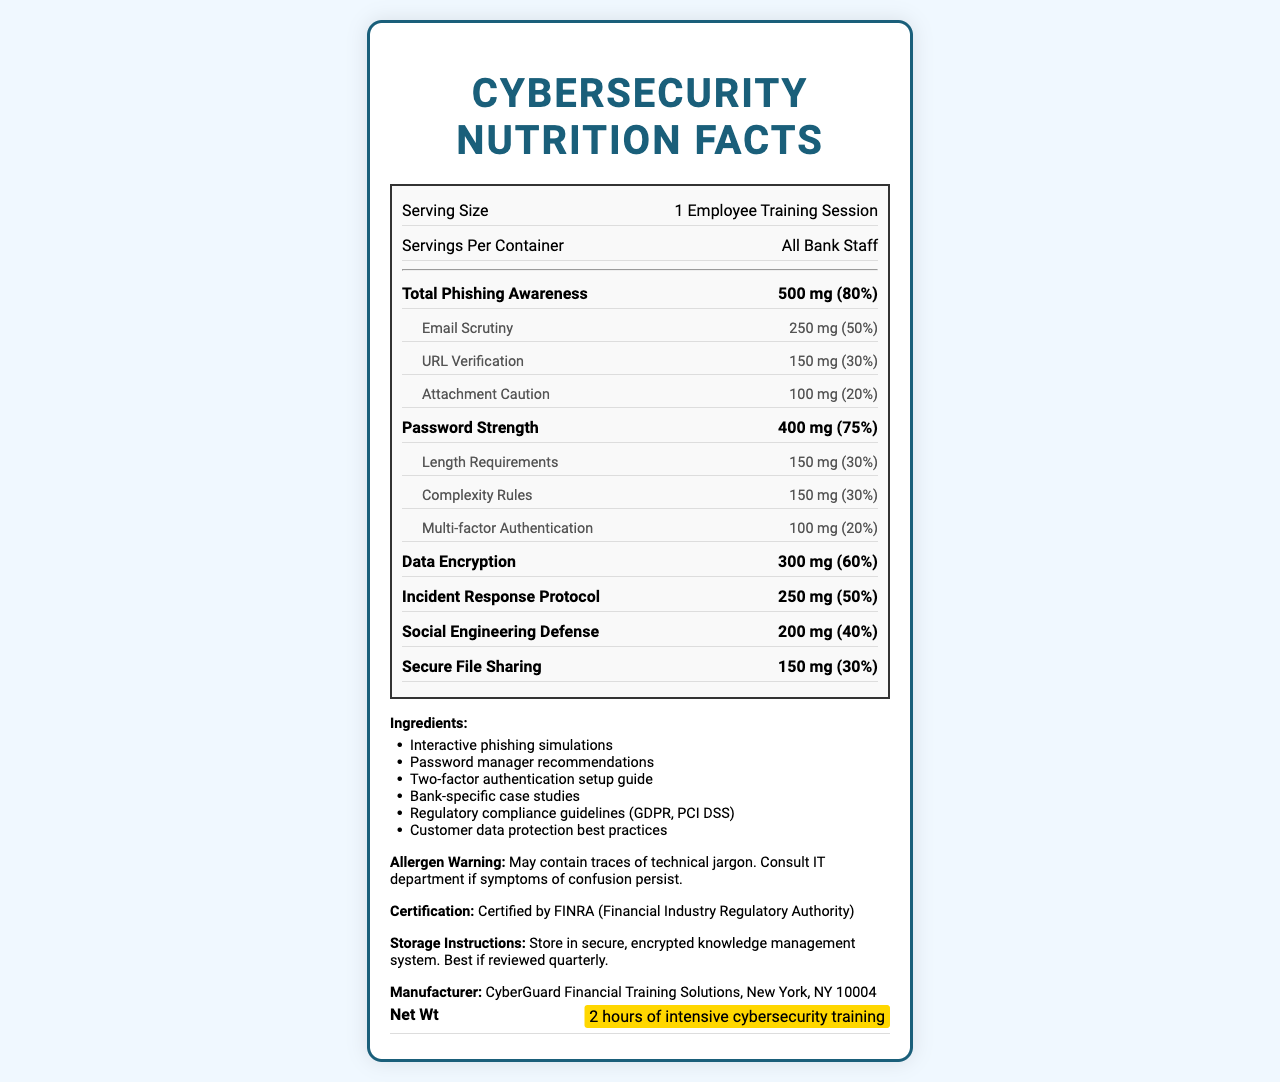what is the serving size? The serving size is mentioned at the top of the document as "Serving Size: 1 Employee Training Session".
Answer: 1 Employee Training Session who is the training session meant for? The "Servings Per Container" section indicates that the training session is meant for "All Bank Staff".
Answer: All Bank Staff how much URL Verification is included in the training session? Under "Nutrition Facts" for "Total Phishing Awareness", it lists "URL Verification" as having "150 mg".
Answer: 150 mg what is the daily value percentage of Password Strength? The document specifies the "dailyValue" for "Password Strength" as "75%".
Answer: 75% what is the allergen warning for? The "Allergen Warning" section at the end of the document states this warning.
Answer: May contain traces of technical jargon. Consult IT department if symptoms of confusion persist. which sub-item under Password Strength has the highest daily value percentage? A. Length Requirements B. Complexity Rules C. Multi-factor Authentication Both "Length Requirements" and "Complexity Rules" have a daily value percentage of "30%", which is higher than "Multi-factor Authentication" which has "20%".
Answer: A, B which of the following is NOT an ingredient in the training? A. Interactive phishing simulations B. Secure coding practices C. Password manager recommendations The "Ingredients" section lists several items, but "Secure coding practices" is not one of them.
Answer: B is this training certified by any authority? The "Certification" section states that the training is "Certified by FINRA (Financial Industry Regulatory Authority)".
Answer: Yes describe the main idea of the document The description should summarize that the document is aimed at presenting a comprehensive cybersecurity training program for bank staff, covering various aspects of cybersecurity preparedness and awareness.
Answer: The document is a creative presentation of a cybersecurity training program for bank staff, styled as a Nutrition Facts label. It details the components and effectiveness of various training elements such as phishing awareness, password strength, data encryption, incident response protocol, social engineering defense, and secure file sharing. It also lists the ingredients included in the training, certification details, storage instructions, and an allergen warning. what are the storage instructions for the training material? The "Storage Instructions" section near the end of the document specifies to store the materials securely and review them quarterly.
Answer: Store in secure, encrypted knowledge management system. Best if reviewed quarterly. what is the net weight of the training program in hours? The "Net Wt" section highlights that the training program is "2 hours of intensive cybersecurity training".
Answer: 2 hours how often should this training be reviewed? According to the "Storage Instructions", the training materials are "Best if reviewed quarterly".
Answer: Quarterly where is the manufacturer of the training solution located? The "Manufacturer" section states "CyberGuard Financial Training Solutions, New York, NY 10004".
Answer: New York, NY 10004 what is the total amount of Incident Response Protocol included? A. 100 mg B. 200 mg C. 250 mg D. 300 mg The "Nutrition Facts" section shows that "Incident Response Protocol" is "250 mg".
Answer: C which item is part of both Phishing Awareness and Password Strength? Each of the sub-items listed under "Phishing Awareness" and "Password Strength" are distinct and do not overlap.
Answer: None does the document state the frequency of phishing simulations in the training? The document lists "Interactive phishing simulations" as an ingredient but does not specify how frequently they occur.
Answer: Not enough information 